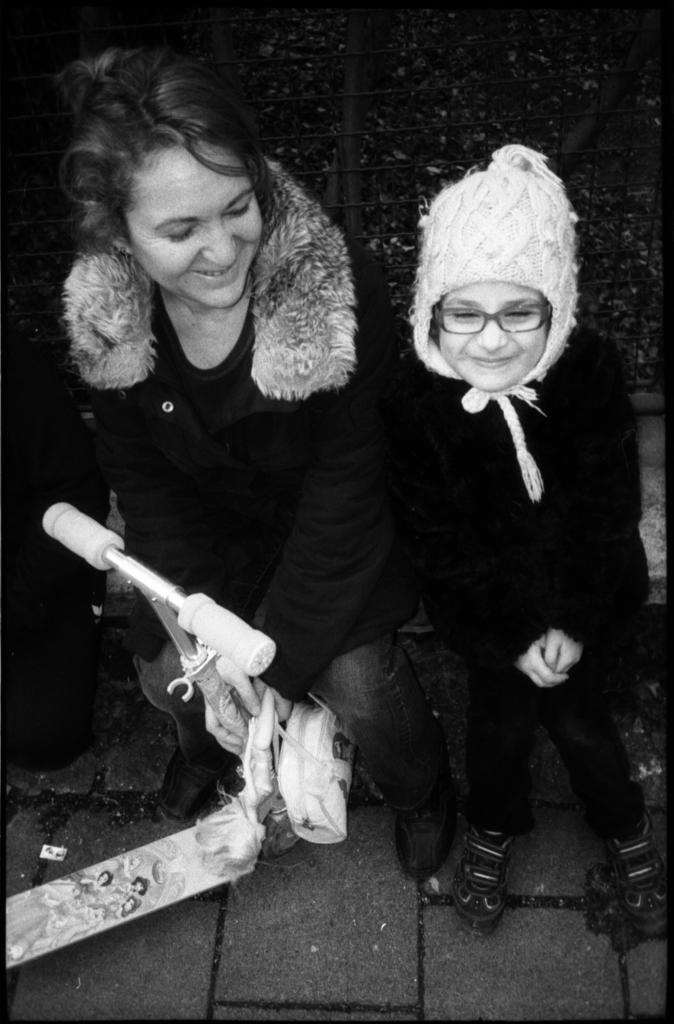Can you describe this image briefly? This is a black and white image. On the left side, there is a woman, sitting, holding a handle of an object and smiling. On the right side, there is a child wearing a cap, smiling and standing. And the background is dark in color. 